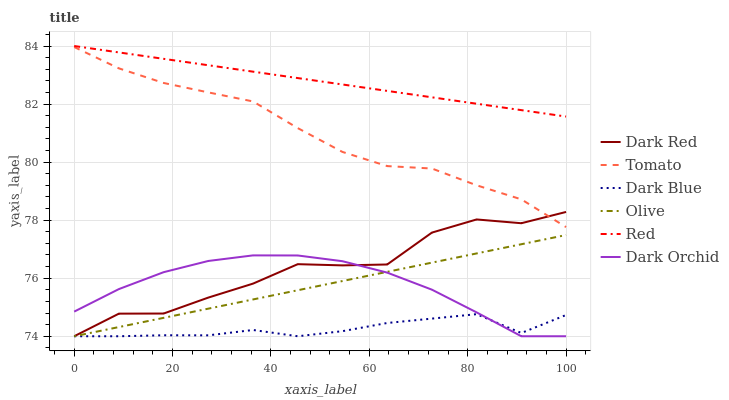Does Dark Blue have the minimum area under the curve?
Answer yes or no. Yes. Does Red have the maximum area under the curve?
Answer yes or no. Yes. Does Dark Red have the minimum area under the curve?
Answer yes or no. No. Does Dark Red have the maximum area under the curve?
Answer yes or no. No. Is Red the smoothest?
Answer yes or no. Yes. Is Dark Red the roughest?
Answer yes or no. Yes. Is Dark Orchid the smoothest?
Answer yes or no. No. Is Dark Orchid the roughest?
Answer yes or no. No. Does Dark Red have the lowest value?
Answer yes or no. Yes. Does Red have the lowest value?
Answer yes or no. No. Does Red have the highest value?
Answer yes or no. Yes. Does Dark Red have the highest value?
Answer yes or no. No. Is Dark Orchid less than Tomato?
Answer yes or no. Yes. Is Red greater than Olive?
Answer yes or no. Yes. Does Dark Red intersect Tomato?
Answer yes or no. Yes. Is Dark Red less than Tomato?
Answer yes or no. No. Is Dark Red greater than Tomato?
Answer yes or no. No. Does Dark Orchid intersect Tomato?
Answer yes or no. No. 